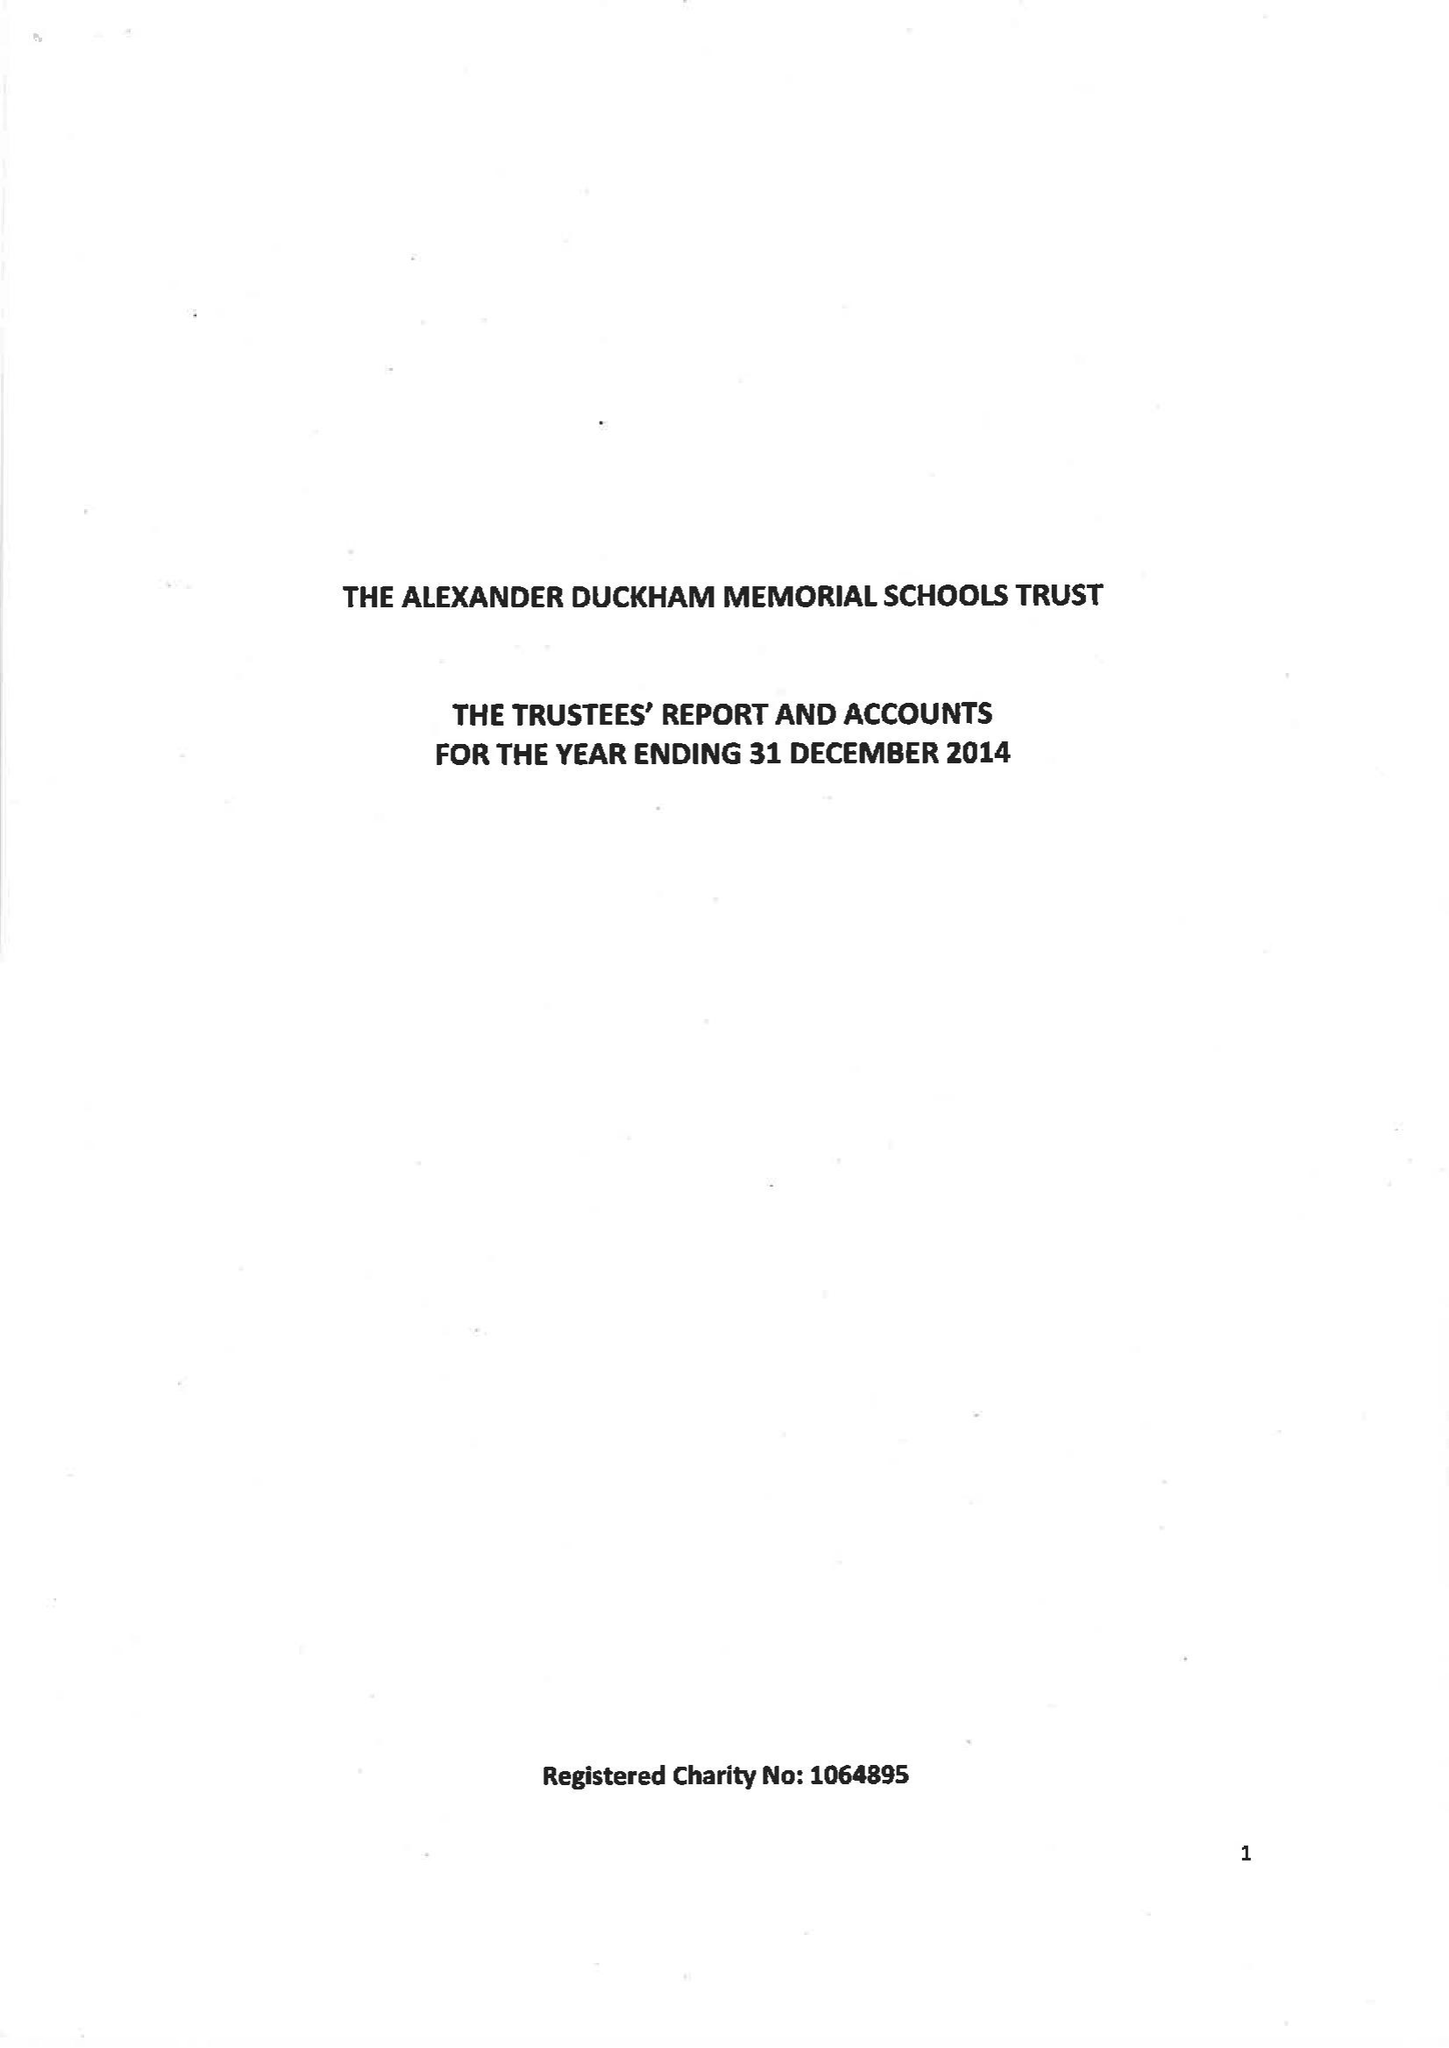What is the value for the spending_annually_in_british_pounds?
Answer the question using a single word or phrase. 89183.00 